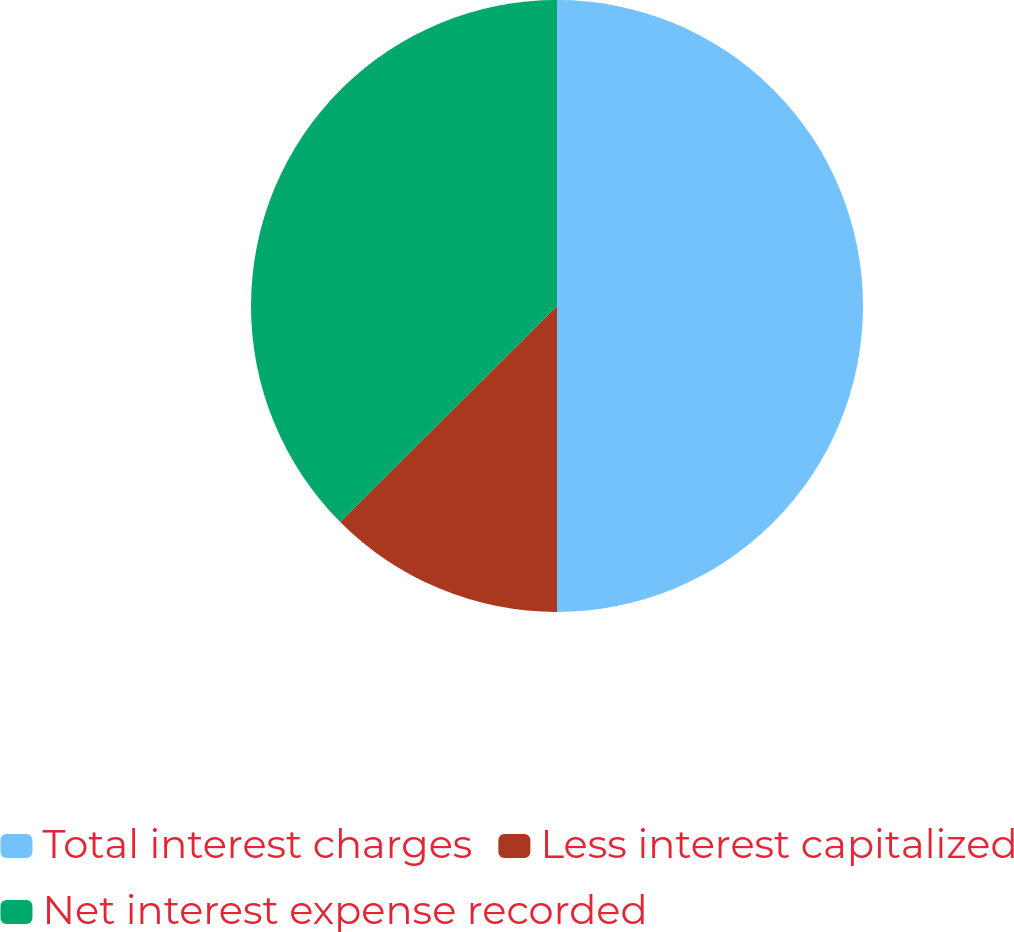Convert chart to OTSL. <chart><loc_0><loc_0><loc_500><loc_500><pie_chart><fcel>Total interest charges<fcel>Less interest capitalized<fcel>Net interest expense recorded<nl><fcel>50.0%<fcel>12.53%<fcel>37.47%<nl></chart> 